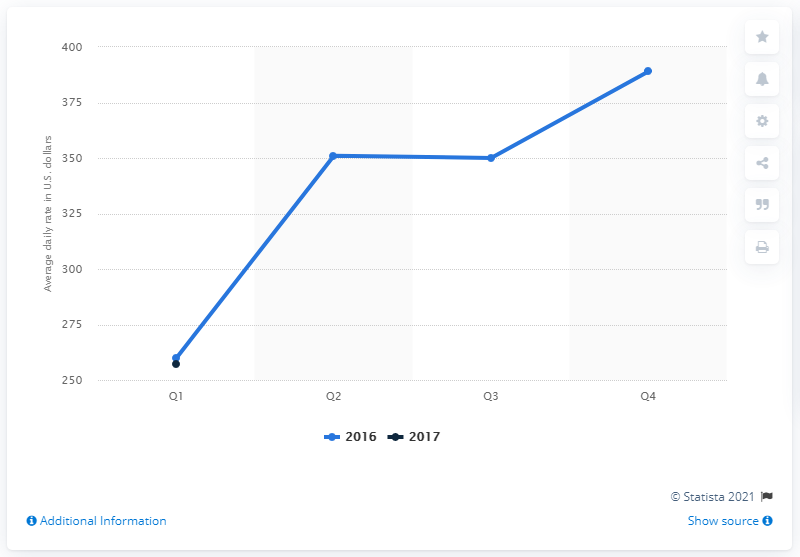Specify some key components in this picture. The average daily rate of hotels in New York during the first quarter of 2017 was approximately $257 per night. 